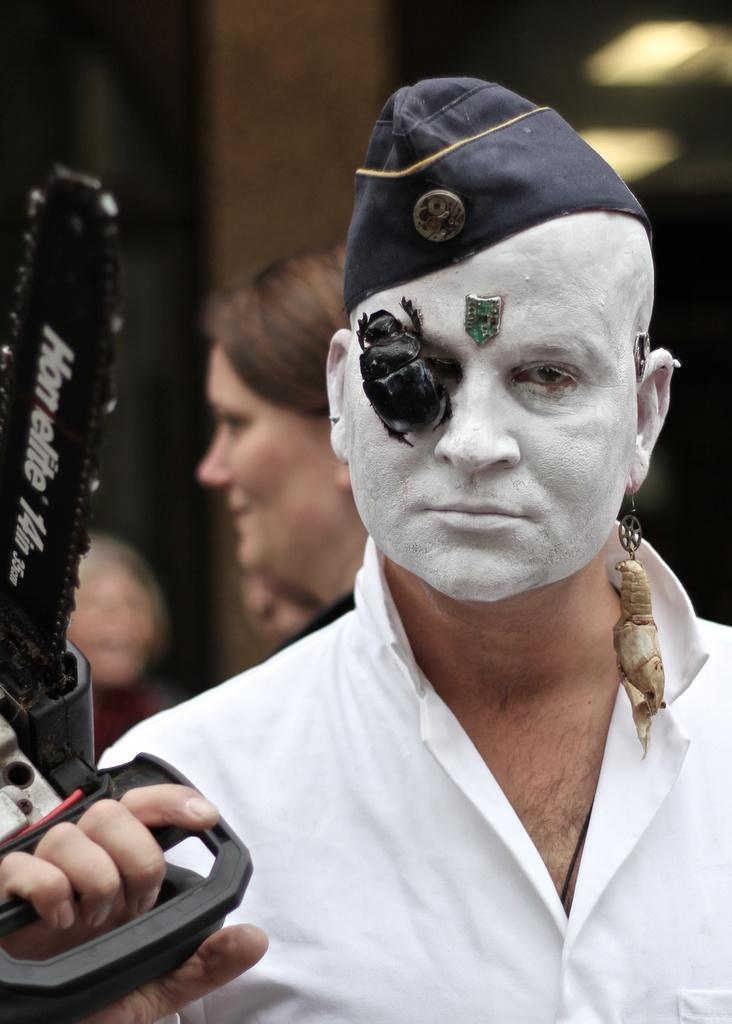What is the person in the image holding? There is a person holding an object in the image. Can you describe anything else about the person's appearance? There is an insect on the person's face. Are there any other people visible in the image? Yes, there are other people behind the person. How would you describe the background of the image? The background of the image is blurred. What type of songs are being sung by the cakes in the image? There are no cakes present in the image, and therefore no songs can be sung by them. 